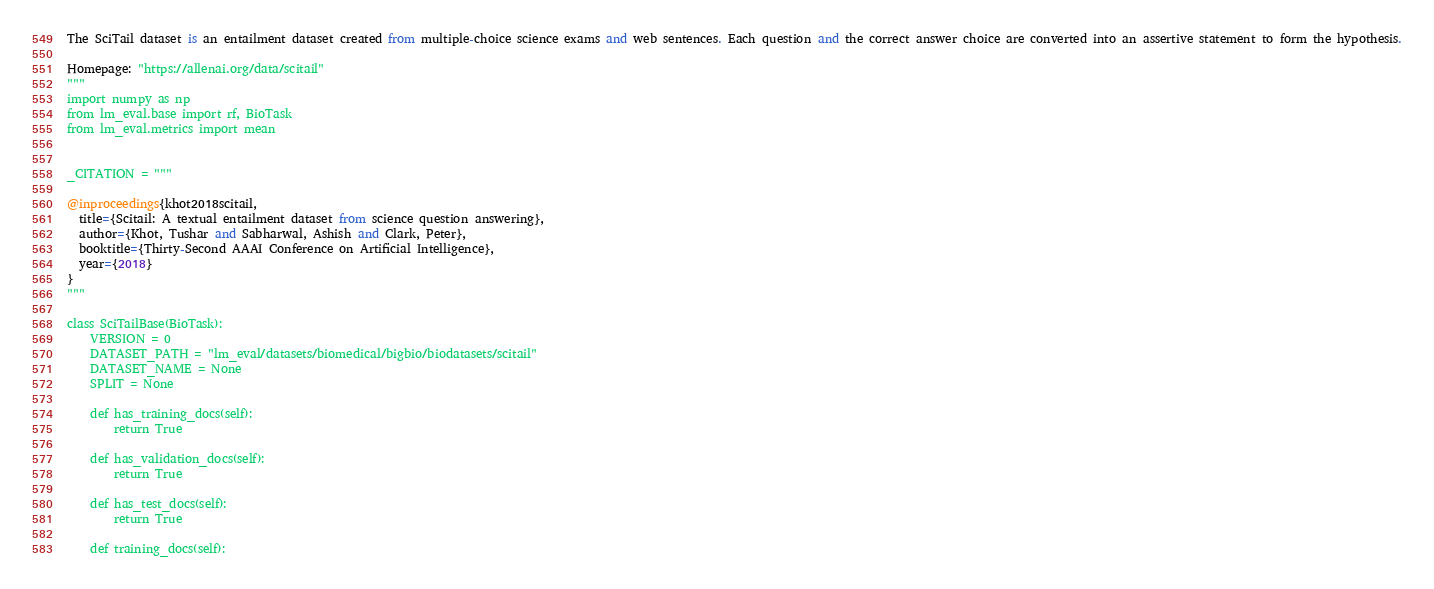<code> <loc_0><loc_0><loc_500><loc_500><_Python_>
The SciTail dataset is an entailment dataset created from multiple-choice science exams and web sentences. Each question and the correct answer choice are converted into an assertive statement to form the hypothesis.

Homepage: "https://allenai.org/data/scitail"
"""
import numpy as np
from lm_eval.base import rf, BioTask
from lm_eval.metrics import mean


_CITATION = """

@inproceedings{khot2018scitail,
  title={Scitail: A textual entailment dataset from science question answering},
  author={Khot, Tushar and Sabharwal, Ashish and Clark, Peter},
  booktitle={Thirty-Second AAAI Conference on Artificial Intelligence},
  year={2018}
}
"""

class SciTailBase(BioTask):
    VERSION = 0
    DATASET_PATH = "lm_eval/datasets/biomedical/bigbio/biodatasets/scitail"
    DATASET_NAME = None
    SPLIT = None

    def has_training_docs(self):
        return True

    def has_validation_docs(self):
        return True

    def has_test_docs(self):
        return True

    def training_docs(self):</code> 